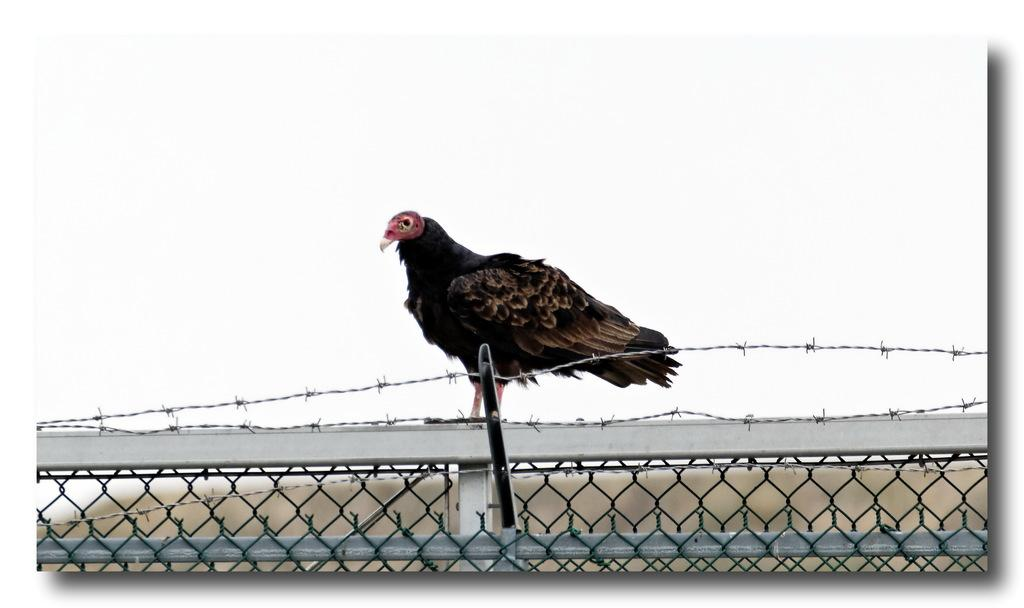What type of animal is in the image? There is a bird in the image. Where is the bird located? The bird is on a fence. What colors can be seen on the bird? The bird has black and brown colors. What can be seen in the background of the image? There is a sky visible in the background of the image. Can you tell me how the bird matches with the fence in the image? There is no information about the bird matching with the fence in the image; we only know that the bird is on the fence. 